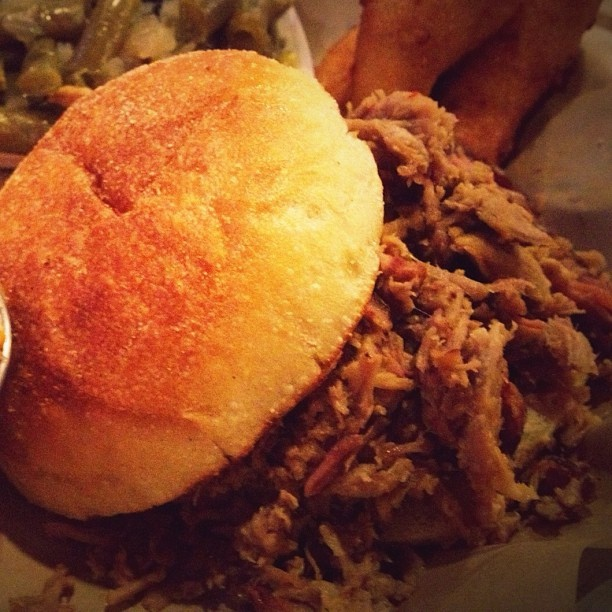Describe the objects in this image and their specific colors. I can see a sandwich in maroon, black, red, and brown tones in this image. 